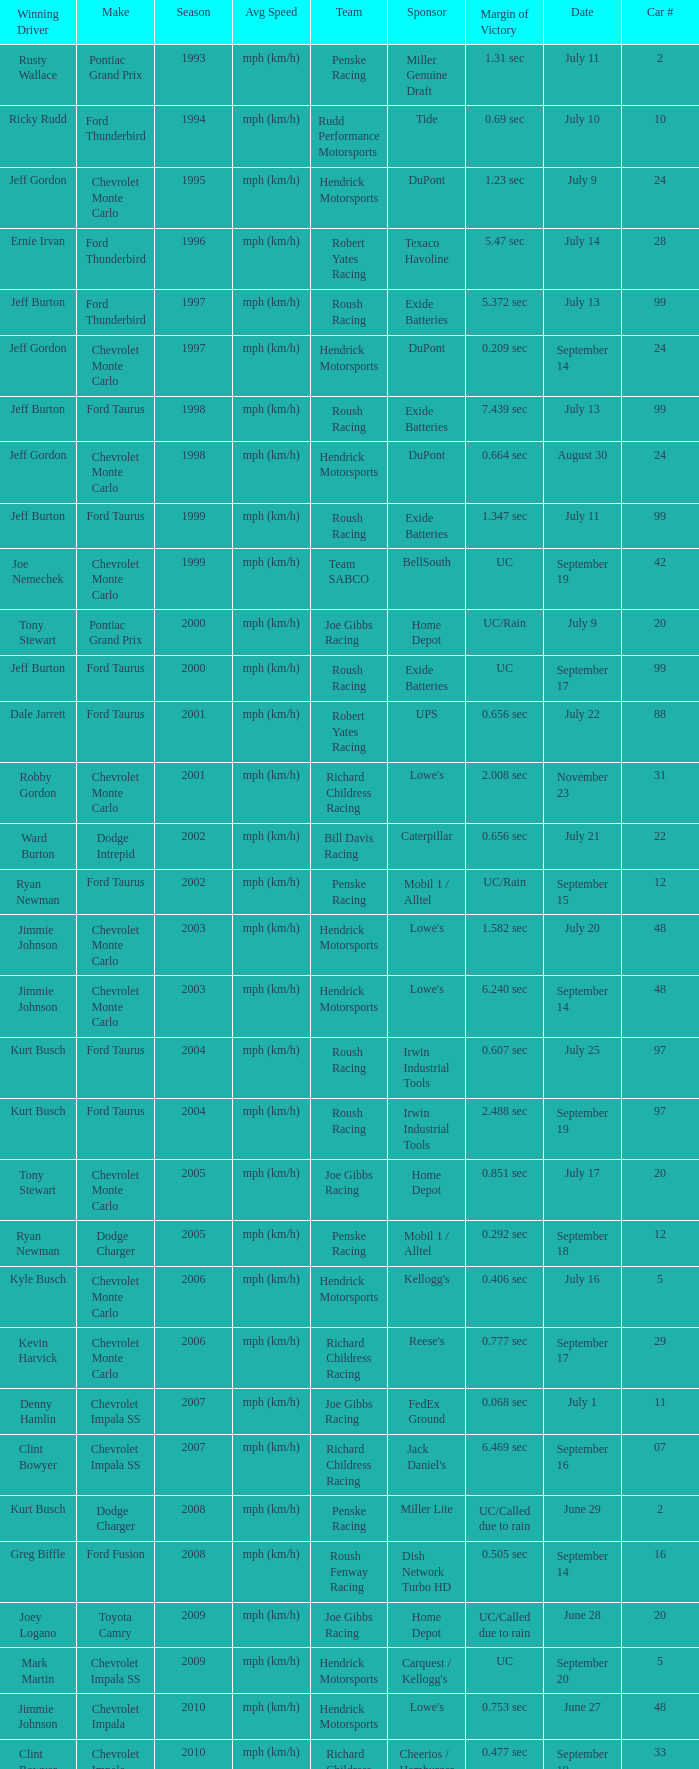What team ran car #24 on August 30? Hendrick Motorsports. 